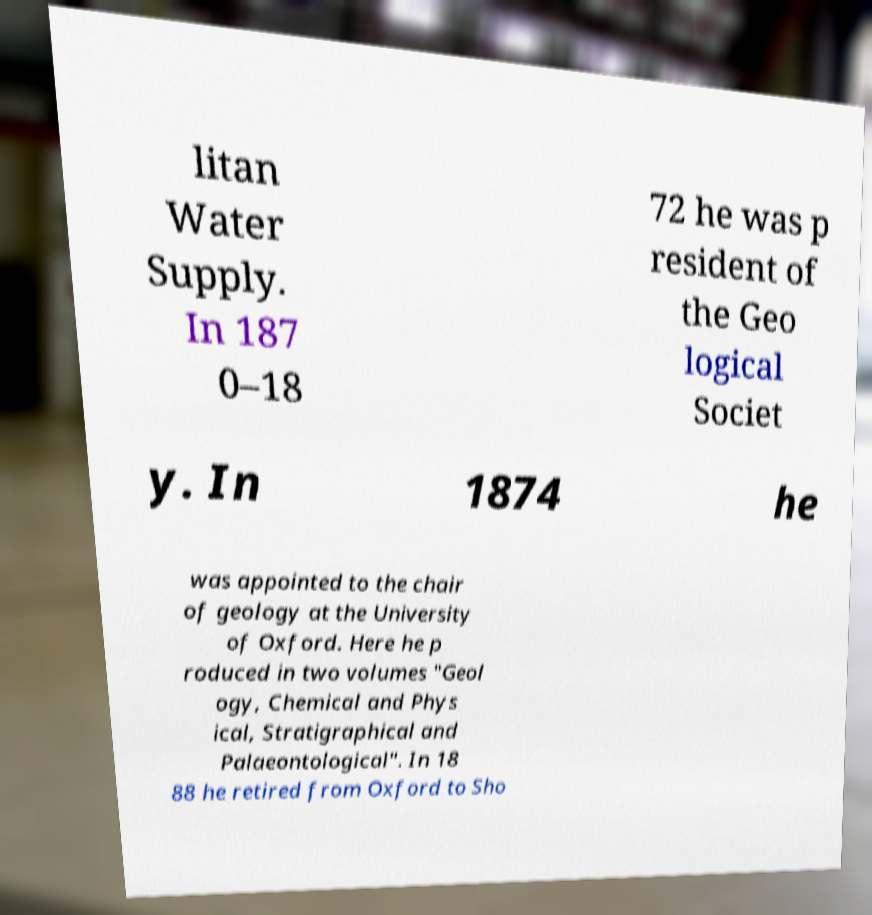Can you accurately transcribe the text from the provided image for me? litan Water Supply. In 187 0–18 72 he was p resident of the Geo logical Societ y. In 1874 he was appointed to the chair of geology at the University of Oxford. Here he p roduced in two volumes "Geol ogy, Chemical and Phys ical, Stratigraphical and Palaeontological". In 18 88 he retired from Oxford to Sho 